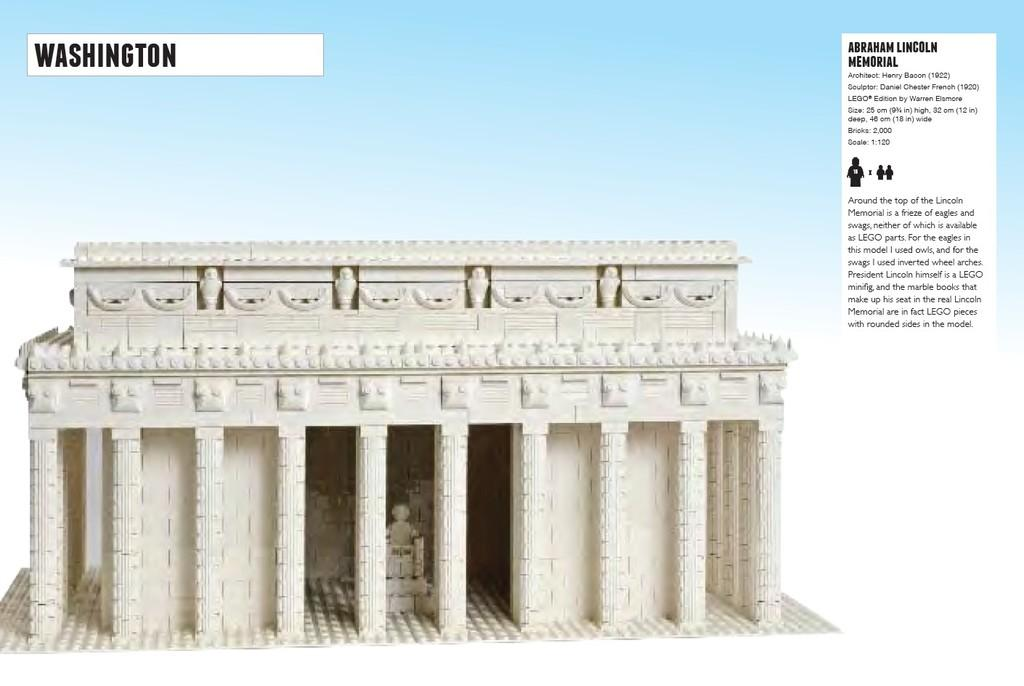What is featured on the poster in the image? There is a poster in the image, and it contains an image of a building. Are there any additional features on the building? Yes, the building has sculptures on it. Where can text be found on the poster? There is text on the right side of the poster and in the left top area of the poster. What type of music is being played by the wool in the image? There is no wool or music present in the image; it only features a poster with an image of a building and text. 